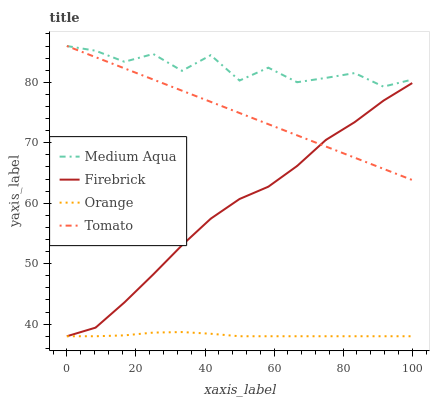Does Orange have the minimum area under the curve?
Answer yes or no. Yes. Does Medium Aqua have the maximum area under the curve?
Answer yes or no. Yes. Does Tomato have the minimum area under the curve?
Answer yes or no. No. Does Tomato have the maximum area under the curve?
Answer yes or no. No. Is Tomato the smoothest?
Answer yes or no. Yes. Is Medium Aqua the roughest?
Answer yes or no. Yes. Is Firebrick the smoothest?
Answer yes or no. No. Is Firebrick the roughest?
Answer yes or no. No. Does Orange have the lowest value?
Answer yes or no. Yes. Does Tomato have the lowest value?
Answer yes or no. No. Does Medium Aqua have the highest value?
Answer yes or no. Yes. Does Firebrick have the highest value?
Answer yes or no. No. Is Firebrick less than Medium Aqua?
Answer yes or no. Yes. Is Medium Aqua greater than Firebrick?
Answer yes or no. Yes. Does Tomato intersect Firebrick?
Answer yes or no. Yes. Is Tomato less than Firebrick?
Answer yes or no. No. Is Tomato greater than Firebrick?
Answer yes or no. No. Does Firebrick intersect Medium Aqua?
Answer yes or no. No. 